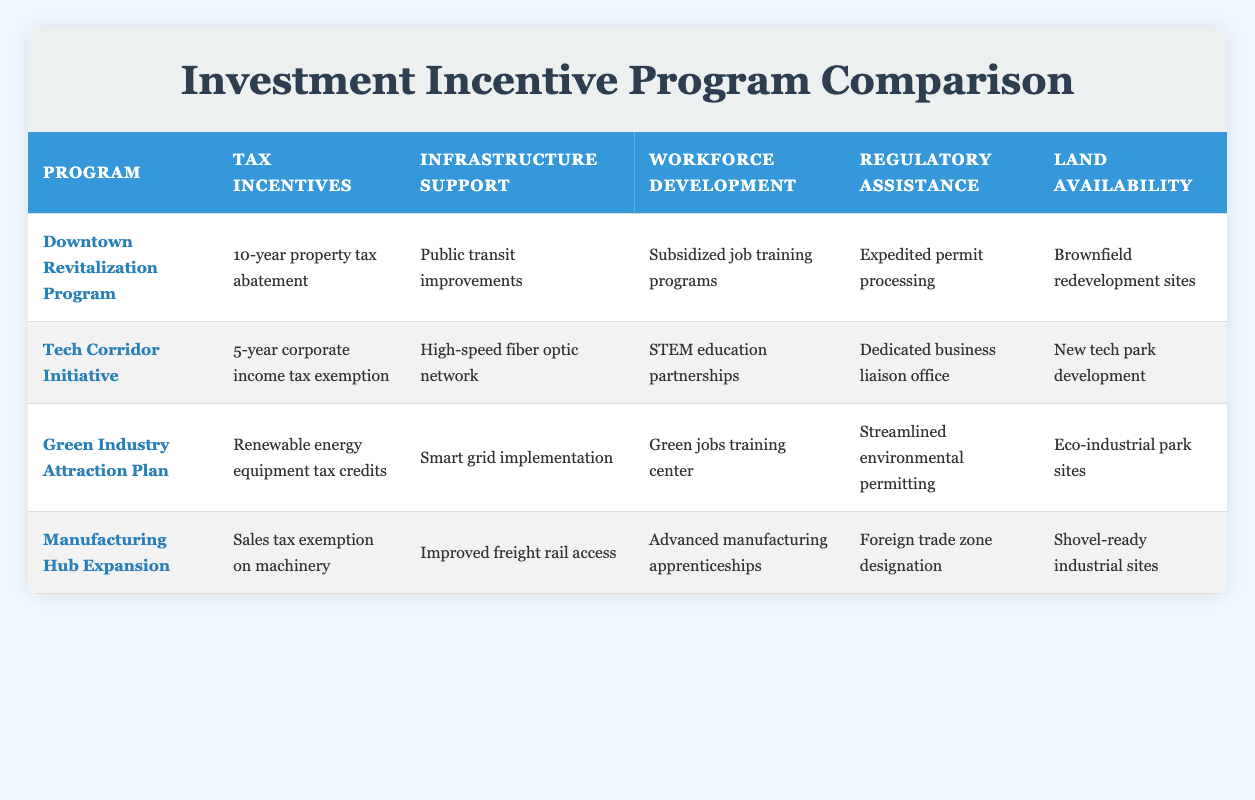What tax incentives are offered in the Downtown Revitalization Program? The Downtown Revitalization Program offers a "10-year property tax abatement" as its tax incentive.
Answer: 10-year property tax abatement Which program provides expedited permit processing? The program that provides expedited permit processing is the "Downtown Revitalization Program."
Answer: Downtown Revitalization Program What is the infrastructure support available in the Tech Corridor Initiative? The Tech Corridor Initiative includes "High-speed fiber optic network" as its infrastructure support.
Answer: High-speed fiber optic network Does the Green Industry Attraction Plan offer any incentives related to renewable energy? Yes, the Green Industry Attraction Plan offers "Renewable energy equipment tax credits" as a tax incentive.
Answer: Yes Which program has the greatest focus on workforce development? Comparing all options, the "Tech Corridor Initiative" and "Green Industry Attraction Plan" both emphasize workforce development; however, the former lists "STEM education partnerships," and the latter has a specific center, making the Green Industry plan's specific training center for green jobs a notable feature.
Answer: Green Industry Attraction Plan How many different types of land availability are mentioned for the programs? There are four unique land availability descriptions: "Brownfield redevelopment sites," "New tech park development," "Eco-industrial park sites," and "Shovel-ready industrial sites." Thus, there are four types listed in the table.
Answer: 4 What tax incentive is common between the Manufacturing Hub Expansion and the Tech Corridor Initiative? The Manufacturing Hub Expansion offers a "Sales tax exemption on machinery," whereas the Tech Corridor Initiative has a "5-year corporate income tax exemption," thus neither option shares a common tax incentive.
Answer: None Identify the programs that include infrastructure support focusing on public services. The Downtown Revitalization Program emphasizes "Public transit improvements," while the Green Industry Attraction Plan highlights the "Smart grid implementation." Both reflect a public service focus.
Answer: Downtown Revitalization Program, Green Industry Attraction Plan Which program has the least duration for tax incentives? The Tech Corridor Initiative features a "5-year corporate income tax exemption," which is the shortest duration for tax incentives among the listed programs.
Answer: Tech Corridor Initiative 